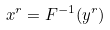<formula> <loc_0><loc_0><loc_500><loc_500>x ^ { r } = F ^ { - 1 } ( y ^ { r } )</formula> 